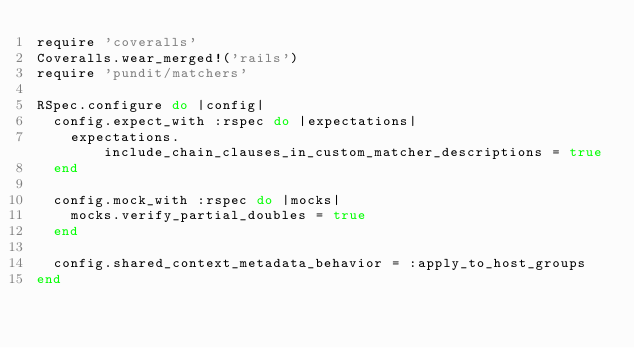Convert code to text. <code><loc_0><loc_0><loc_500><loc_500><_Ruby_>require 'coveralls'
Coveralls.wear_merged!('rails')
require 'pundit/matchers'

RSpec.configure do |config|
  config.expect_with :rspec do |expectations|
    expectations.include_chain_clauses_in_custom_matcher_descriptions = true
  end

  config.mock_with :rspec do |mocks|
    mocks.verify_partial_doubles = true
  end

  config.shared_context_metadata_behavior = :apply_to_host_groups
end
</code> 